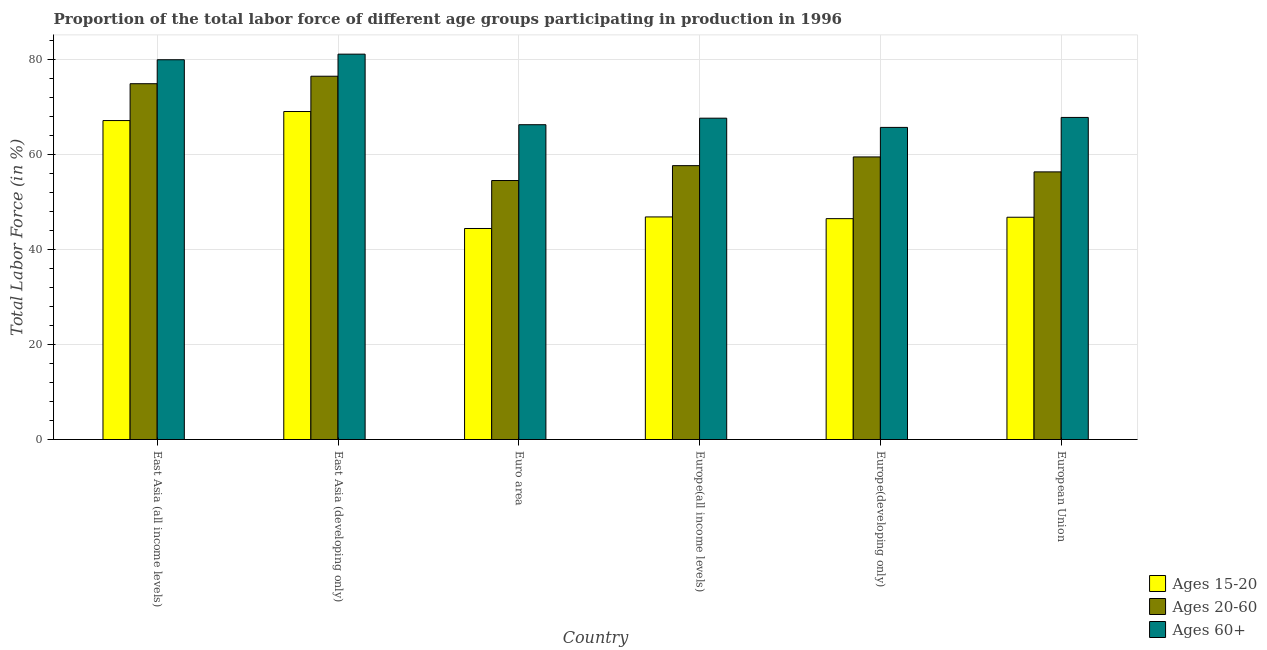How many different coloured bars are there?
Your answer should be compact. 3. How many groups of bars are there?
Ensure brevity in your answer.  6. Are the number of bars per tick equal to the number of legend labels?
Your answer should be very brief. Yes. Are the number of bars on each tick of the X-axis equal?
Provide a short and direct response. Yes. How many bars are there on the 6th tick from the left?
Your answer should be compact. 3. What is the label of the 2nd group of bars from the left?
Offer a terse response. East Asia (developing only). What is the percentage of labor force above age 60 in Europe(all income levels)?
Provide a succinct answer. 67.59. Across all countries, what is the maximum percentage of labor force within the age group 20-60?
Give a very brief answer. 76.41. Across all countries, what is the minimum percentage of labor force within the age group 15-20?
Provide a short and direct response. 44.38. In which country was the percentage of labor force within the age group 20-60 maximum?
Your response must be concise. East Asia (developing only). What is the total percentage of labor force above age 60 in the graph?
Give a very brief answer. 428.13. What is the difference between the percentage of labor force above age 60 in East Asia (all income levels) and that in Europe(all income levels)?
Offer a very short reply. 12.29. What is the difference between the percentage of labor force above age 60 in Euro area and the percentage of labor force within the age group 20-60 in European Union?
Offer a terse response. 9.92. What is the average percentage of labor force above age 60 per country?
Provide a succinct answer. 71.36. What is the difference between the percentage of labor force above age 60 and percentage of labor force within the age group 15-20 in Europe(all income levels)?
Give a very brief answer. 20.77. In how many countries, is the percentage of labor force within the age group 20-60 greater than 56 %?
Make the answer very short. 5. What is the ratio of the percentage of labor force within the age group 15-20 in East Asia (developing only) to that in Europe(all income levels)?
Your answer should be compact. 1.47. Is the percentage of labor force within the age group 20-60 in East Asia (all income levels) less than that in Europe(developing only)?
Give a very brief answer. No. Is the difference between the percentage of labor force within the age group 15-20 in East Asia (developing only) and Europe(developing only) greater than the difference between the percentage of labor force within the age group 20-60 in East Asia (developing only) and Europe(developing only)?
Keep it short and to the point. Yes. What is the difference between the highest and the second highest percentage of labor force above age 60?
Keep it short and to the point. 1.18. What is the difference between the highest and the lowest percentage of labor force above age 60?
Provide a short and direct response. 15.41. Is the sum of the percentage of labor force within the age group 15-20 in Euro area and European Union greater than the maximum percentage of labor force within the age group 20-60 across all countries?
Give a very brief answer. Yes. What does the 3rd bar from the left in East Asia (all income levels) represents?
Provide a short and direct response. Ages 60+. What does the 2nd bar from the right in European Union represents?
Provide a succinct answer. Ages 20-60. Are the values on the major ticks of Y-axis written in scientific E-notation?
Offer a very short reply. No. Does the graph contain grids?
Offer a very short reply. Yes. How many legend labels are there?
Keep it short and to the point. 3. What is the title of the graph?
Offer a terse response. Proportion of the total labor force of different age groups participating in production in 1996. Does "Primary education" appear as one of the legend labels in the graph?
Your response must be concise. No. What is the label or title of the X-axis?
Give a very brief answer. Country. What is the Total Labor Force (in %) of Ages 15-20 in East Asia (all income levels)?
Offer a very short reply. 67.09. What is the Total Labor Force (in %) in Ages 20-60 in East Asia (all income levels)?
Provide a succinct answer. 74.84. What is the Total Labor Force (in %) in Ages 60+ in East Asia (all income levels)?
Your response must be concise. 79.88. What is the Total Labor Force (in %) in Ages 15-20 in East Asia (developing only)?
Give a very brief answer. 68.99. What is the Total Labor Force (in %) of Ages 20-60 in East Asia (developing only)?
Your answer should be compact. 76.41. What is the Total Labor Force (in %) in Ages 60+ in East Asia (developing only)?
Your answer should be very brief. 81.06. What is the Total Labor Force (in %) in Ages 15-20 in Euro area?
Your answer should be very brief. 44.38. What is the Total Labor Force (in %) in Ages 20-60 in Euro area?
Offer a very short reply. 54.47. What is the Total Labor Force (in %) of Ages 60+ in Euro area?
Make the answer very short. 66.21. What is the Total Labor Force (in %) of Ages 15-20 in Europe(all income levels)?
Your answer should be compact. 46.82. What is the Total Labor Force (in %) in Ages 20-60 in Europe(all income levels)?
Ensure brevity in your answer.  57.6. What is the Total Labor Force (in %) of Ages 60+ in Europe(all income levels)?
Give a very brief answer. 67.59. What is the Total Labor Force (in %) in Ages 15-20 in Europe(developing only)?
Your response must be concise. 46.46. What is the Total Labor Force (in %) in Ages 20-60 in Europe(developing only)?
Your answer should be very brief. 59.44. What is the Total Labor Force (in %) in Ages 60+ in Europe(developing only)?
Give a very brief answer. 65.65. What is the Total Labor Force (in %) in Ages 15-20 in European Union?
Provide a short and direct response. 46.75. What is the Total Labor Force (in %) of Ages 20-60 in European Union?
Offer a terse response. 56.29. What is the Total Labor Force (in %) of Ages 60+ in European Union?
Offer a very short reply. 67.75. Across all countries, what is the maximum Total Labor Force (in %) of Ages 15-20?
Your answer should be very brief. 68.99. Across all countries, what is the maximum Total Labor Force (in %) of Ages 20-60?
Make the answer very short. 76.41. Across all countries, what is the maximum Total Labor Force (in %) in Ages 60+?
Your response must be concise. 81.06. Across all countries, what is the minimum Total Labor Force (in %) in Ages 15-20?
Provide a succinct answer. 44.38. Across all countries, what is the minimum Total Labor Force (in %) in Ages 20-60?
Offer a very short reply. 54.47. Across all countries, what is the minimum Total Labor Force (in %) of Ages 60+?
Offer a very short reply. 65.65. What is the total Total Labor Force (in %) in Ages 15-20 in the graph?
Provide a succinct answer. 320.49. What is the total Total Labor Force (in %) in Ages 20-60 in the graph?
Make the answer very short. 379.06. What is the total Total Labor Force (in %) in Ages 60+ in the graph?
Your response must be concise. 428.13. What is the difference between the Total Labor Force (in %) in Ages 15-20 in East Asia (all income levels) and that in East Asia (developing only)?
Keep it short and to the point. -1.9. What is the difference between the Total Labor Force (in %) in Ages 20-60 in East Asia (all income levels) and that in East Asia (developing only)?
Provide a short and direct response. -1.57. What is the difference between the Total Labor Force (in %) in Ages 60+ in East Asia (all income levels) and that in East Asia (developing only)?
Make the answer very short. -1.18. What is the difference between the Total Labor Force (in %) in Ages 15-20 in East Asia (all income levels) and that in Euro area?
Provide a succinct answer. 22.7. What is the difference between the Total Labor Force (in %) in Ages 20-60 in East Asia (all income levels) and that in Euro area?
Give a very brief answer. 20.36. What is the difference between the Total Labor Force (in %) in Ages 60+ in East Asia (all income levels) and that in Euro area?
Provide a short and direct response. 13.66. What is the difference between the Total Labor Force (in %) of Ages 15-20 in East Asia (all income levels) and that in Europe(all income levels)?
Ensure brevity in your answer.  20.27. What is the difference between the Total Labor Force (in %) in Ages 20-60 in East Asia (all income levels) and that in Europe(all income levels)?
Your answer should be very brief. 17.23. What is the difference between the Total Labor Force (in %) in Ages 60+ in East Asia (all income levels) and that in Europe(all income levels)?
Ensure brevity in your answer.  12.29. What is the difference between the Total Labor Force (in %) in Ages 15-20 in East Asia (all income levels) and that in Europe(developing only)?
Your answer should be very brief. 20.63. What is the difference between the Total Labor Force (in %) in Ages 20-60 in East Asia (all income levels) and that in Europe(developing only)?
Ensure brevity in your answer.  15.4. What is the difference between the Total Labor Force (in %) of Ages 60+ in East Asia (all income levels) and that in Europe(developing only)?
Your answer should be compact. 14.23. What is the difference between the Total Labor Force (in %) in Ages 15-20 in East Asia (all income levels) and that in European Union?
Provide a short and direct response. 20.34. What is the difference between the Total Labor Force (in %) in Ages 20-60 in East Asia (all income levels) and that in European Union?
Give a very brief answer. 18.55. What is the difference between the Total Labor Force (in %) of Ages 60+ in East Asia (all income levels) and that in European Union?
Your answer should be compact. 12.13. What is the difference between the Total Labor Force (in %) of Ages 15-20 in East Asia (developing only) and that in Euro area?
Your answer should be compact. 24.6. What is the difference between the Total Labor Force (in %) in Ages 20-60 in East Asia (developing only) and that in Euro area?
Give a very brief answer. 21.94. What is the difference between the Total Labor Force (in %) in Ages 60+ in East Asia (developing only) and that in Euro area?
Ensure brevity in your answer.  14.84. What is the difference between the Total Labor Force (in %) in Ages 15-20 in East Asia (developing only) and that in Europe(all income levels)?
Offer a very short reply. 22.17. What is the difference between the Total Labor Force (in %) in Ages 20-60 in East Asia (developing only) and that in Europe(all income levels)?
Give a very brief answer. 18.81. What is the difference between the Total Labor Force (in %) of Ages 60+ in East Asia (developing only) and that in Europe(all income levels)?
Give a very brief answer. 13.47. What is the difference between the Total Labor Force (in %) of Ages 15-20 in East Asia (developing only) and that in Europe(developing only)?
Offer a very short reply. 22.53. What is the difference between the Total Labor Force (in %) of Ages 20-60 in East Asia (developing only) and that in Europe(developing only)?
Offer a terse response. 16.97. What is the difference between the Total Labor Force (in %) of Ages 60+ in East Asia (developing only) and that in Europe(developing only)?
Your response must be concise. 15.41. What is the difference between the Total Labor Force (in %) in Ages 15-20 in East Asia (developing only) and that in European Union?
Keep it short and to the point. 22.24. What is the difference between the Total Labor Force (in %) in Ages 20-60 in East Asia (developing only) and that in European Union?
Keep it short and to the point. 20.12. What is the difference between the Total Labor Force (in %) of Ages 60+ in East Asia (developing only) and that in European Union?
Provide a short and direct response. 13.31. What is the difference between the Total Labor Force (in %) of Ages 15-20 in Euro area and that in Europe(all income levels)?
Provide a succinct answer. -2.43. What is the difference between the Total Labor Force (in %) in Ages 20-60 in Euro area and that in Europe(all income levels)?
Give a very brief answer. -3.13. What is the difference between the Total Labor Force (in %) of Ages 60+ in Euro area and that in Europe(all income levels)?
Your response must be concise. -1.37. What is the difference between the Total Labor Force (in %) in Ages 15-20 in Euro area and that in Europe(developing only)?
Offer a very short reply. -2.07. What is the difference between the Total Labor Force (in %) in Ages 20-60 in Euro area and that in Europe(developing only)?
Keep it short and to the point. -4.96. What is the difference between the Total Labor Force (in %) in Ages 60+ in Euro area and that in Europe(developing only)?
Your response must be concise. 0.56. What is the difference between the Total Labor Force (in %) in Ages 15-20 in Euro area and that in European Union?
Your answer should be compact. -2.37. What is the difference between the Total Labor Force (in %) of Ages 20-60 in Euro area and that in European Union?
Provide a succinct answer. -1.82. What is the difference between the Total Labor Force (in %) of Ages 60+ in Euro area and that in European Union?
Your response must be concise. -1.53. What is the difference between the Total Labor Force (in %) in Ages 15-20 in Europe(all income levels) and that in Europe(developing only)?
Your answer should be compact. 0.36. What is the difference between the Total Labor Force (in %) in Ages 20-60 in Europe(all income levels) and that in Europe(developing only)?
Keep it short and to the point. -1.83. What is the difference between the Total Labor Force (in %) in Ages 60+ in Europe(all income levels) and that in Europe(developing only)?
Your answer should be very brief. 1.94. What is the difference between the Total Labor Force (in %) of Ages 15-20 in Europe(all income levels) and that in European Union?
Offer a terse response. 0.07. What is the difference between the Total Labor Force (in %) of Ages 20-60 in Europe(all income levels) and that in European Union?
Offer a very short reply. 1.31. What is the difference between the Total Labor Force (in %) of Ages 60+ in Europe(all income levels) and that in European Union?
Provide a short and direct response. -0.16. What is the difference between the Total Labor Force (in %) in Ages 15-20 in Europe(developing only) and that in European Union?
Provide a short and direct response. -0.29. What is the difference between the Total Labor Force (in %) of Ages 20-60 in Europe(developing only) and that in European Union?
Provide a short and direct response. 3.14. What is the difference between the Total Labor Force (in %) in Ages 60+ in Europe(developing only) and that in European Union?
Your answer should be very brief. -2.1. What is the difference between the Total Labor Force (in %) of Ages 15-20 in East Asia (all income levels) and the Total Labor Force (in %) of Ages 20-60 in East Asia (developing only)?
Ensure brevity in your answer.  -9.32. What is the difference between the Total Labor Force (in %) of Ages 15-20 in East Asia (all income levels) and the Total Labor Force (in %) of Ages 60+ in East Asia (developing only)?
Make the answer very short. -13.97. What is the difference between the Total Labor Force (in %) of Ages 20-60 in East Asia (all income levels) and the Total Labor Force (in %) of Ages 60+ in East Asia (developing only)?
Provide a short and direct response. -6.22. What is the difference between the Total Labor Force (in %) in Ages 15-20 in East Asia (all income levels) and the Total Labor Force (in %) in Ages 20-60 in Euro area?
Your answer should be very brief. 12.61. What is the difference between the Total Labor Force (in %) in Ages 15-20 in East Asia (all income levels) and the Total Labor Force (in %) in Ages 60+ in Euro area?
Offer a very short reply. 0.87. What is the difference between the Total Labor Force (in %) in Ages 20-60 in East Asia (all income levels) and the Total Labor Force (in %) in Ages 60+ in Euro area?
Make the answer very short. 8.62. What is the difference between the Total Labor Force (in %) in Ages 15-20 in East Asia (all income levels) and the Total Labor Force (in %) in Ages 20-60 in Europe(all income levels)?
Your response must be concise. 9.48. What is the difference between the Total Labor Force (in %) of Ages 15-20 in East Asia (all income levels) and the Total Labor Force (in %) of Ages 60+ in Europe(all income levels)?
Your response must be concise. -0.5. What is the difference between the Total Labor Force (in %) of Ages 20-60 in East Asia (all income levels) and the Total Labor Force (in %) of Ages 60+ in Europe(all income levels)?
Offer a very short reply. 7.25. What is the difference between the Total Labor Force (in %) in Ages 15-20 in East Asia (all income levels) and the Total Labor Force (in %) in Ages 20-60 in Europe(developing only)?
Provide a short and direct response. 7.65. What is the difference between the Total Labor Force (in %) in Ages 15-20 in East Asia (all income levels) and the Total Labor Force (in %) in Ages 60+ in Europe(developing only)?
Offer a terse response. 1.44. What is the difference between the Total Labor Force (in %) in Ages 20-60 in East Asia (all income levels) and the Total Labor Force (in %) in Ages 60+ in Europe(developing only)?
Your answer should be compact. 9.19. What is the difference between the Total Labor Force (in %) of Ages 15-20 in East Asia (all income levels) and the Total Labor Force (in %) of Ages 20-60 in European Union?
Keep it short and to the point. 10.79. What is the difference between the Total Labor Force (in %) in Ages 15-20 in East Asia (all income levels) and the Total Labor Force (in %) in Ages 60+ in European Union?
Make the answer very short. -0.66. What is the difference between the Total Labor Force (in %) of Ages 20-60 in East Asia (all income levels) and the Total Labor Force (in %) of Ages 60+ in European Union?
Offer a very short reply. 7.09. What is the difference between the Total Labor Force (in %) of Ages 15-20 in East Asia (developing only) and the Total Labor Force (in %) of Ages 20-60 in Euro area?
Your answer should be very brief. 14.52. What is the difference between the Total Labor Force (in %) of Ages 15-20 in East Asia (developing only) and the Total Labor Force (in %) of Ages 60+ in Euro area?
Ensure brevity in your answer.  2.77. What is the difference between the Total Labor Force (in %) of Ages 20-60 in East Asia (developing only) and the Total Labor Force (in %) of Ages 60+ in Euro area?
Give a very brief answer. 10.2. What is the difference between the Total Labor Force (in %) of Ages 15-20 in East Asia (developing only) and the Total Labor Force (in %) of Ages 20-60 in Europe(all income levels)?
Keep it short and to the point. 11.39. What is the difference between the Total Labor Force (in %) of Ages 15-20 in East Asia (developing only) and the Total Labor Force (in %) of Ages 60+ in Europe(all income levels)?
Your answer should be compact. 1.4. What is the difference between the Total Labor Force (in %) of Ages 20-60 in East Asia (developing only) and the Total Labor Force (in %) of Ages 60+ in Europe(all income levels)?
Offer a terse response. 8.82. What is the difference between the Total Labor Force (in %) in Ages 15-20 in East Asia (developing only) and the Total Labor Force (in %) in Ages 20-60 in Europe(developing only)?
Your answer should be compact. 9.55. What is the difference between the Total Labor Force (in %) in Ages 15-20 in East Asia (developing only) and the Total Labor Force (in %) in Ages 60+ in Europe(developing only)?
Give a very brief answer. 3.34. What is the difference between the Total Labor Force (in %) of Ages 20-60 in East Asia (developing only) and the Total Labor Force (in %) of Ages 60+ in Europe(developing only)?
Keep it short and to the point. 10.76. What is the difference between the Total Labor Force (in %) of Ages 15-20 in East Asia (developing only) and the Total Labor Force (in %) of Ages 20-60 in European Union?
Your response must be concise. 12.7. What is the difference between the Total Labor Force (in %) of Ages 15-20 in East Asia (developing only) and the Total Labor Force (in %) of Ages 60+ in European Union?
Your answer should be compact. 1.24. What is the difference between the Total Labor Force (in %) in Ages 20-60 in East Asia (developing only) and the Total Labor Force (in %) in Ages 60+ in European Union?
Your answer should be very brief. 8.67. What is the difference between the Total Labor Force (in %) in Ages 15-20 in Euro area and the Total Labor Force (in %) in Ages 20-60 in Europe(all income levels)?
Provide a short and direct response. -13.22. What is the difference between the Total Labor Force (in %) in Ages 15-20 in Euro area and the Total Labor Force (in %) in Ages 60+ in Europe(all income levels)?
Offer a terse response. -23.2. What is the difference between the Total Labor Force (in %) of Ages 20-60 in Euro area and the Total Labor Force (in %) of Ages 60+ in Europe(all income levels)?
Keep it short and to the point. -13.11. What is the difference between the Total Labor Force (in %) in Ages 15-20 in Euro area and the Total Labor Force (in %) in Ages 20-60 in Europe(developing only)?
Offer a very short reply. -15.05. What is the difference between the Total Labor Force (in %) of Ages 15-20 in Euro area and the Total Labor Force (in %) of Ages 60+ in Europe(developing only)?
Provide a short and direct response. -21.26. What is the difference between the Total Labor Force (in %) in Ages 20-60 in Euro area and the Total Labor Force (in %) in Ages 60+ in Europe(developing only)?
Give a very brief answer. -11.18. What is the difference between the Total Labor Force (in %) in Ages 15-20 in Euro area and the Total Labor Force (in %) in Ages 20-60 in European Union?
Keep it short and to the point. -11.91. What is the difference between the Total Labor Force (in %) of Ages 15-20 in Euro area and the Total Labor Force (in %) of Ages 60+ in European Union?
Provide a short and direct response. -23.36. What is the difference between the Total Labor Force (in %) of Ages 20-60 in Euro area and the Total Labor Force (in %) of Ages 60+ in European Union?
Ensure brevity in your answer.  -13.27. What is the difference between the Total Labor Force (in %) in Ages 15-20 in Europe(all income levels) and the Total Labor Force (in %) in Ages 20-60 in Europe(developing only)?
Provide a succinct answer. -12.62. What is the difference between the Total Labor Force (in %) in Ages 15-20 in Europe(all income levels) and the Total Labor Force (in %) in Ages 60+ in Europe(developing only)?
Offer a very short reply. -18.83. What is the difference between the Total Labor Force (in %) of Ages 20-60 in Europe(all income levels) and the Total Labor Force (in %) of Ages 60+ in Europe(developing only)?
Keep it short and to the point. -8.05. What is the difference between the Total Labor Force (in %) of Ages 15-20 in Europe(all income levels) and the Total Labor Force (in %) of Ages 20-60 in European Union?
Keep it short and to the point. -9.48. What is the difference between the Total Labor Force (in %) in Ages 15-20 in Europe(all income levels) and the Total Labor Force (in %) in Ages 60+ in European Union?
Your response must be concise. -20.93. What is the difference between the Total Labor Force (in %) in Ages 20-60 in Europe(all income levels) and the Total Labor Force (in %) in Ages 60+ in European Union?
Make the answer very short. -10.14. What is the difference between the Total Labor Force (in %) in Ages 15-20 in Europe(developing only) and the Total Labor Force (in %) in Ages 20-60 in European Union?
Your answer should be compact. -9.84. What is the difference between the Total Labor Force (in %) of Ages 15-20 in Europe(developing only) and the Total Labor Force (in %) of Ages 60+ in European Union?
Your answer should be very brief. -21.29. What is the difference between the Total Labor Force (in %) of Ages 20-60 in Europe(developing only) and the Total Labor Force (in %) of Ages 60+ in European Union?
Provide a succinct answer. -8.31. What is the average Total Labor Force (in %) of Ages 15-20 per country?
Ensure brevity in your answer.  53.41. What is the average Total Labor Force (in %) of Ages 20-60 per country?
Make the answer very short. 63.18. What is the average Total Labor Force (in %) in Ages 60+ per country?
Offer a very short reply. 71.36. What is the difference between the Total Labor Force (in %) of Ages 15-20 and Total Labor Force (in %) of Ages 20-60 in East Asia (all income levels)?
Ensure brevity in your answer.  -7.75. What is the difference between the Total Labor Force (in %) in Ages 15-20 and Total Labor Force (in %) in Ages 60+ in East Asia (all income levels)?
Your answer should be compact. -12.79. What is the difference between the Total Labor Force (in %) in Ages 20-60 and Total Labor Force (in %) in Ages 60+ in East Asia (all income levels)?
Your answer should be very brief. -5.04. What is the difference between the Total Labor Force (in %) of Ages 15-20 and Total Labor Force (in %) of Ages 20-60 in East Asia (developing only)?
Offer a terse response. -7.42. What is the difference between the Total Labor Force (in %) in Ages 15-20 and Total Labor Force (in %) in Ages 60+ in East Asia (developing only)?
Ensure brevity in your answer.  -12.07. What is the difference between the Total Labor Force (in %) of Ages 20-60 and Total Labor Force (in %) of Ages 60+ in East Asia (developing only)?
Your answer should be very brief. -4.65. What is the difference between the Total Labor Force (in %) in Ages 15-20 and Total Labor Force (in %) in Ages 20-60 in Euro area?
Offer a very short reply. -10.09. What is the difference between the Total Labor Force (in %) of Ages 15-20 and Total Labor Force (in %) of Ages 60+ in Euro area?
Ensure brevity in your answer.  -21.83. What is the difference between the Total Labor Force (in %) in Ages 20-60 and Total Labor Force (in %) in Ages 60+ in Euro area?
Your answer should be very brief. -11.74. What is the difference between the Total Labor Force (in %) in Ages 15-20 and Total Labor Force (in %) in Ages 20-60 in Europe(all income levels)?
Provide a succinct answer. -10.79. What is the difference between the Total Labor Force (in %) in Ages 15-20 and Total Labor Force (in %) in Ages 60+ in Europe(all income levels)?
Offer a terse response. -20.77. What is the difference between the Total Labor Force (in %) of Ages 20-60 and Total Labor Force (in %) of Ages 60+ in Europe(all income levels)?
Your response must be concise. -9.98. What is the difference between the Total Labor Force (in %) in Ages 15-20 and Total Labor Force (in %) in Ages 20-60 in Europe(developing only)?
Your response must be concise. -12.98. What is the difference between the Total Labor Force (in %) in Ages 15-20 and Total Labor Force (in %) in Ages 60+ in Europe(developing only)?
Provide a succinct answer. -19.19. What is the difference between the Total Labor Force (in %) of Ages 20-60 and Total Labor Force (in %) of Ages 60+ in Europe(developing only)?
Make the answer very short. -6.21. What is the difference between the Total Labor Force (in %) in Ages 15-20 and Total Labor Force (in %) in Ages 20-60 in European Union?
Your answer should be compact. -9.54. What is the difference between the Total Labor Force (in %) in Ages 15-20 and Total Labor Force (in %) in Ages 60+ in European Union?
Provide a succinct answer. -20.99. What is the difference between the Total Labor Force (in %) of Ages 20-60 and Total Labor Force (in %) of Ages 60+ in European Union?
Your response must be concise. -11.45. What is the ratio of the Total Labor Force (in %) of Ages 15-20 in East Asia (all income levels) to that in East Asia (developing only)?
Offer a very short reply. 0.97. What is the ratio of the Total Labor Force (in %) in Ages 20-60 in East Asia (all income levels) to that in East Asia (developing only)?
Offer a very short reply. 0.98. What is the ratio of the Total Labor Force (in %) in Ages 60+ in East Asia (all income levels) to that in East Asia (developing only)?
Make the answer very short. 0.99. What is the ratio of the Total Labor Force (in %) in Ages 15-20 in East Asia (all income levels) to that in Euro area?
Offer a very short reply. 1.51. What is the ratio of the Total Labor Force (in %) in Ages 20-60 in East Asia (all income levels) to that in Euro area?
Your answer should be very brief. 1.37. What is the ratio of the Total Labor Force (in %) of Ages 60+ in East Asia (all income levels) to that in Euro area?
Give a very brief answer. 1.21. What is the ratio of the Total Labor Force (in %) in Ages 15-20 in East Asia (all income levels) to that in Europe(all income levels)?
Provide a succinct answer. 1.43. What is the ratio of the Total Labor Force (in %) in Ages 20-60 in East Asia (all income levels) to that in Europe(all income levels)?
Give a very brief answer. 1.3. What is the ratio of the Total Labor Force (in %) in Ages 60+ in East Asia (all income levels) to that in Europe(all income levels)?
Your answer should be compact. 1.18. What is the ratio of the Total Labor Force (in %) in Ages 15-20 in East Asia (all income levels) to that in Europe(developing only)?
Provide a succinct answer. 1.44. What is the ratio of the Total Labor Force (in %) of Ages 20-60 in East Asia (all income levels) to that in Europe(developing only)?
Provide a short and direct response. 1.26. What is the ratio of the Total Labor Force (in %) in Ages 60+ in East Asia (all income levels) to that in Europe(developing only)?
Give a very brief answer. 1.22. What is the ratio of the Total Labor Force (in %) of Ages 15-20 in East Asia (all income levels) to that in European Union?
Provide a succinct answer. 1.44. What is the ratio of the Total Labor Force (in %) in Ages 20-60 in East Asia (all income levels) to that in European Union?
Your answer should be very brief. 1.33. What is the ratio of the Total Labor Force (in %) in Ages 60+ in East Asia (all income levels) to that in European Union?
Offer a terse response. 1.18. What is the ratio of the Total Labor Force (in %) of Ages 15-20 in East Asia (developing only) to that in Euro area?
Your answer should be very brief. 1.55. What is the ratio of the Total Labor Force (in %) in Ages 20-60 in East Asia (developing only) to that in Euro area?
Provide a succinct answer. 1.4. What is the ratio of the Total Labor Force (in %) in Ages 60+ in East Asia (developing only) to that in Euro area?
Your answer should be compact. 1.22. What is the ratio of the Total Labor Force (in %) in Ages 15-20 in East Asia (developing only) to that in Europe(all income levels)?
Offer a very short reply. 1.47. What is the ratio of the Total Labor Force (in %) in Ages 20-60 in East Asia (developing only) to that in Europe(all income levels)?
Ensure brevity in your answer.  1.33. What is the ratio of the Total Labor Force (in %) in Ages 60+ in East Asia (developing only) to that in Europe(all income levels)?
Keep it short and to the point. 1.2. What is the ratio of the Total Labor Force (in %) of Ages 15-20 in East Asia (developing only) to that in Europe(developing only)?
Offer a very short reply. 1.49. What is the ratio of the Total Labor Force (in %) of Ages 20-60 in East Asia (developing only) to that in Europe(developing only)?
Offer a terse response. 1.29. What is the ratio of the Total Labor Force (in %) of Ages 60+ in East Asia (developing only) to that in Europe(developing only)?
Provide a succinct answer. 1.23. What is the ratio of the Total Labor Force (in %) in Ages 15-20 in East Asia (developing only) to that in European Union?
Ensure brevity in your answer.  1.48. What is the ratio of the Total Labor Force (in %) of Ages 20-60 in East Asia (developing only) to that in European Union?
Give a very brief answer. 1.36. What is the ratio of the Total Labor Force (in %) of Ages 60+ in East Asia (developing only) to that in European Union?
Offer a very short reply. 1.2. What is the ratio of the Total Labor Force (in %) of Ages 15-20 in Euro area to that in Europe(all income levels)?
Your answer should be very brief. 0.95. What is the ratio of the Total Labor Force (in %) of Ages 20-60 in Euro area to that in Europe(all income levels)?
Provide a succinct answer. 0.95. What is the ratio of the Total Labor Force (in %) in Ages 60+ in Euro area to that in Europe(all income levels)?
Make the answer very short. 0.98. What is the ratio of the Total Labor Force (in %) in Ages 15-20 in Euro area to that in Europe(developing only)?
Give a very brief answer. 0.96. What is the ratio of the Total Labor Force (in %) of Ages 20-60 in Euro area to that in Europe(developing only)?
Offer a very short reply. 0.92. What is the ratio of the Total Labor Force (in %) of Ages 60+ in Euro area to that in Europe(developing only)?
Provide a succinct answer. 1.01. What is the ratio of the Total Labor Force (in %) of Ages 15-20 in Euro area to that in European Union?
Offer a very short reply. 0.95. What is the ratio of the Total Labor Force (in %) of Ages 20-60 in Euro area to that in European Union?
Give a very brief answer. 0.97. What is the ratio of the Total Labor Force (in %) of Ages 60+ in Euro area to that in European Union?
Ensure brevity in your answer.  0.98. What is the ratio of the Total Labor Force (in %) in Ages 20-60 in Europe(all income levels) to that in Europe(developing only)?
Offer a terse response. 0.97. What is the ratio of the Total Labor Force (in %) of Ages 60+ in Europe(all income levels) to that in Europe(developing only)?
Ensure brevity in your answer.  1.03. What is the ratio of the Total Labor Force (in %) of Ages 15-20 in Europe(all income levels) to that in European Union?
Give a very brief answer. 1. What is the ratio of the Total Labor Force (in %) in Ages 20-60 in Europe(all income levels) to that in European Union?
Make the answer very short. 1.02. What is the ratio of the Total Labor Force (in %) of Ages 60+ in Europe(all income levels) to that in European Union?
Offer a terse response. 1. What is the ratio of the Total Labor Force (in %) in Ages 15-20 in Europe(developing only) to that in European Union?
Offer a very short reply. 0.99. What is the ratio of the Total Labor Force (in %) of Ages 20-60 in Europe(developing only) to that in European Union?
Give a very brief answer. 1.06. What is the ratio of the Total Labor Force (in %) of Ages 60+ in Europe(developing only) to that in European Union?
Provide a succinct answer. 0.97. What is the difference between the highest and the second highest Total Labor Force (in %) in Ages 15-20?
Your answer should be very brief. 1.9. What is the difference between the highest and the second highest Total Labor Force (in %) of Ages 20-60?
Your answer should be compact. 1.57. What is the difference between the highest and the second highest Total Labor Force (in %) in Ages 60+?
Provide a short and direct response. 1.18. What is the difference between the highest and the lowest Total Labor Force (in %) of Ages 15-20?
Provide a succinct answer. 24.6. What is the difference between the highest and the lowest Total Labor Force (in %) of Ages 20-60?
Offer a very short reply. 21.94. What is the difference between the highest and the lowest Total Labor Force (in %) in Ages 60+?
Ensure brevity in your answer.  15.41. 